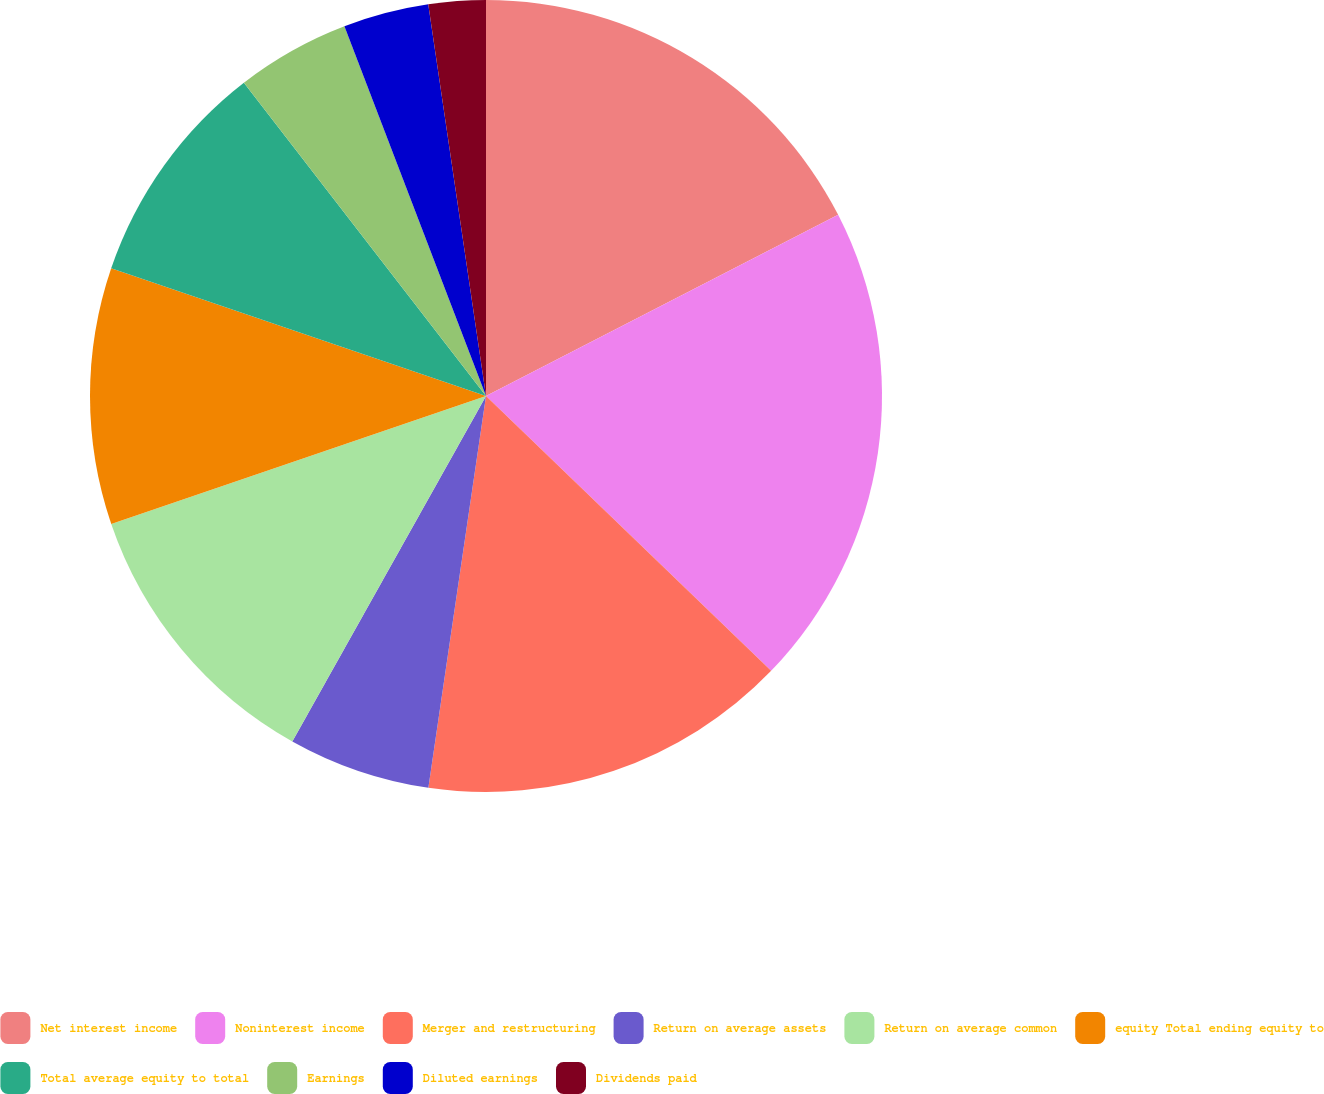Convert chart. <chart><loc_0><loc_0><loc_500><loc_500><pie_chart><fcel>Net interest income<fcel>Noninterest income<fcel>Merger and restructuring<fcel>Return on average assets<fcel>Return on average common<fcel>equity Total ending equity to<fcel>Total average equity to total<fcel>Earnings<fcel>Diluted earnings<fcel>Dividends paid<nl><fcel>17.44%<fcel>19.77%<fcel>15.12%<fcel>5.81%<fcel>11.63%<fcel>10.47%<fcel>9.3%<fcel>4.65%<fcel>3.49%<fcel>2.33%<nl></chart> 